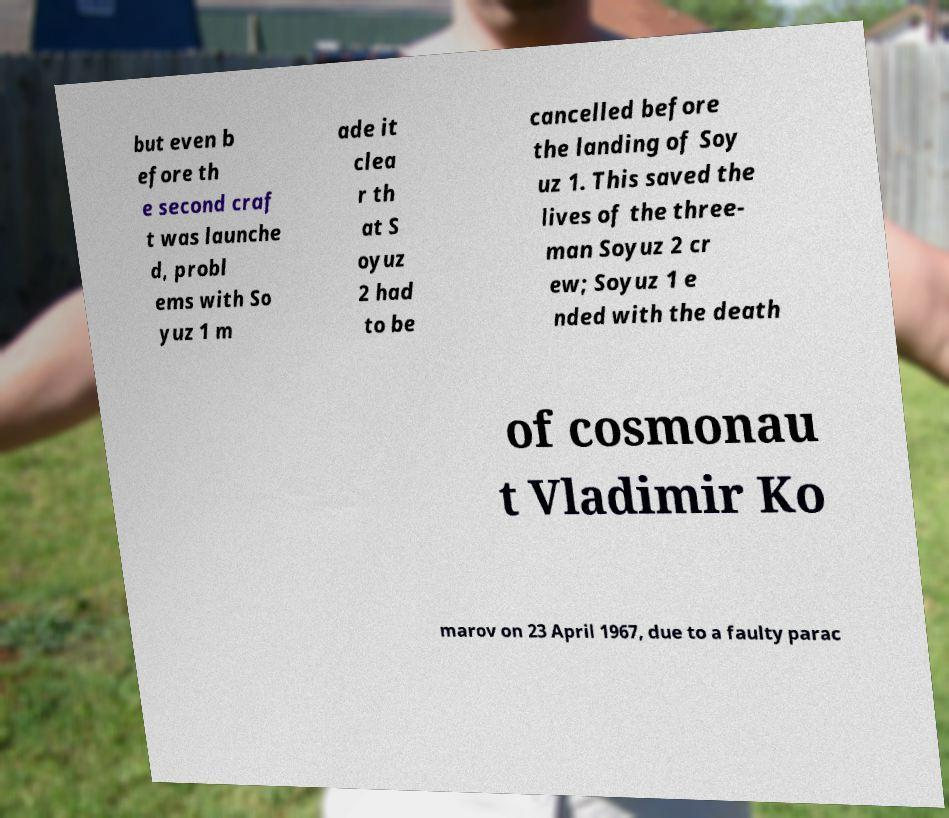Please identify and transcribe the text found in this image. but even b efore th e second craf t was launche d, probl ems with So yuz 1 m ade it clea r th at S oyuz 2 had to be cancelled before the landing of Soy uz 1. This saved the lives of the three- man Soyuz 2 cr ew; Soyuz 1 e nded with the death of cosmonau t Vladimir Ko marov on 23 April 1967, due to a faulty parac 